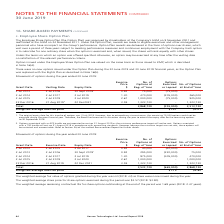According to Hansen Technologies's financial document, How many options granted on 2 July 2015 were exercised or lapsed? According to the financial document, 75,000. The relevant text states: "2 Jul 2013 2 Jul 2016 30 Sept 2018 1 0.92 75,000 (75,000) -..." Also, Why were there no new options issued under the Option Plan during the 30 June 2019 and 30 June 2018 financial years? as the Option Plan was replaced with the Rights Plan. The document states: "he 30 June 2019 and 30 June 2018 financial years, as the Option Plan was replaced with the Rights Plan as described in Note 16(b)...." Also, What was the exercise price for options granted on 2 July 2014? According to the financial document, 1.30. The relevant text states: "2 Jul 2014 2 Jul 2017 2 Jul 2019 1.30 470,000 (205,000) 265,000..." Also, can you calculate: What was the total percentage change in number of options at beginning of the year for options granted between 2013 and 2016? To answer this question, I need to perform calculations using the financial data. The calculation is: (1,323,730 - 75,000) / 75,000 , which equals 1664.97 (percentage). This is based on the information: "22 Dec 2016 31 Aug 2019 2 22 Dec2021 3.59 1,323,730 - 1,323,730 2 Jul 2013 2 Jul 2016 30 Sept 2018 1 0.92 75,000 (75,000) -..." The key data points involved are: 1,323,730, 75,000. Also, can you calculate: What was the total weighted exercise cost for all options that were exercised or lapsed? Based on the calculation: 355,000 * $1.51 , the result is 536050. This is based on the information: "Total 2,868,730 (355,000) 2,513,730 Weighted average exercise price $1.51 $3.01..." The key data points involved are: 1.51, 355,000. Also, can you calculate: What was the total percentage change in exercise price for options granted between 2013 and 2016? To answer this question, I need to perform calculations using the financial data. The calculation is: (3.59 - 0.92) / 0.92 , which equals 290.22 (percentage). This is based on the information: "22 Dec 2016 31 Aug 2019 2 22 Dec2021 3.59 1,323,730 - 1,323,730 2 Jul 2013 2 Jul 2016 30 Sept 2018 1 0.92 75,000 (75,000) -..." The key data points involved are: 0.92, 3.59. 